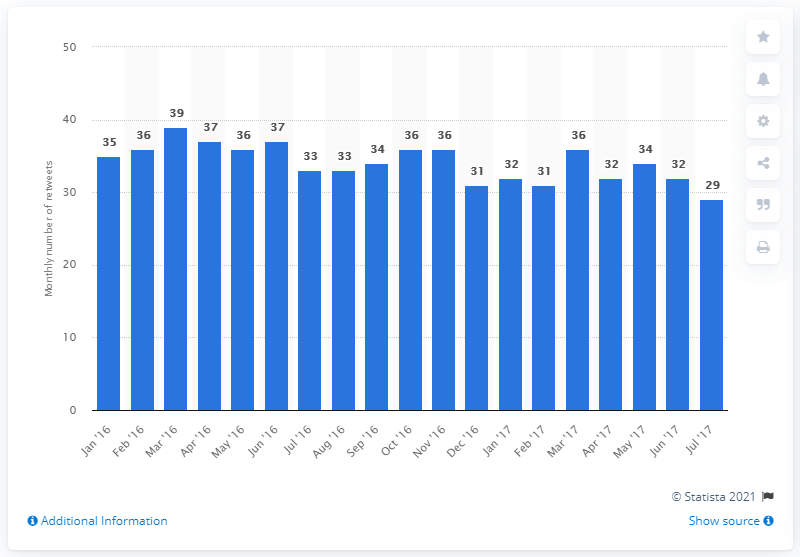Outline some significant characteristics in this image. During the last month, the average number of retweets by brands on Twitter was 29. There were 32 retweets in the previous month. 